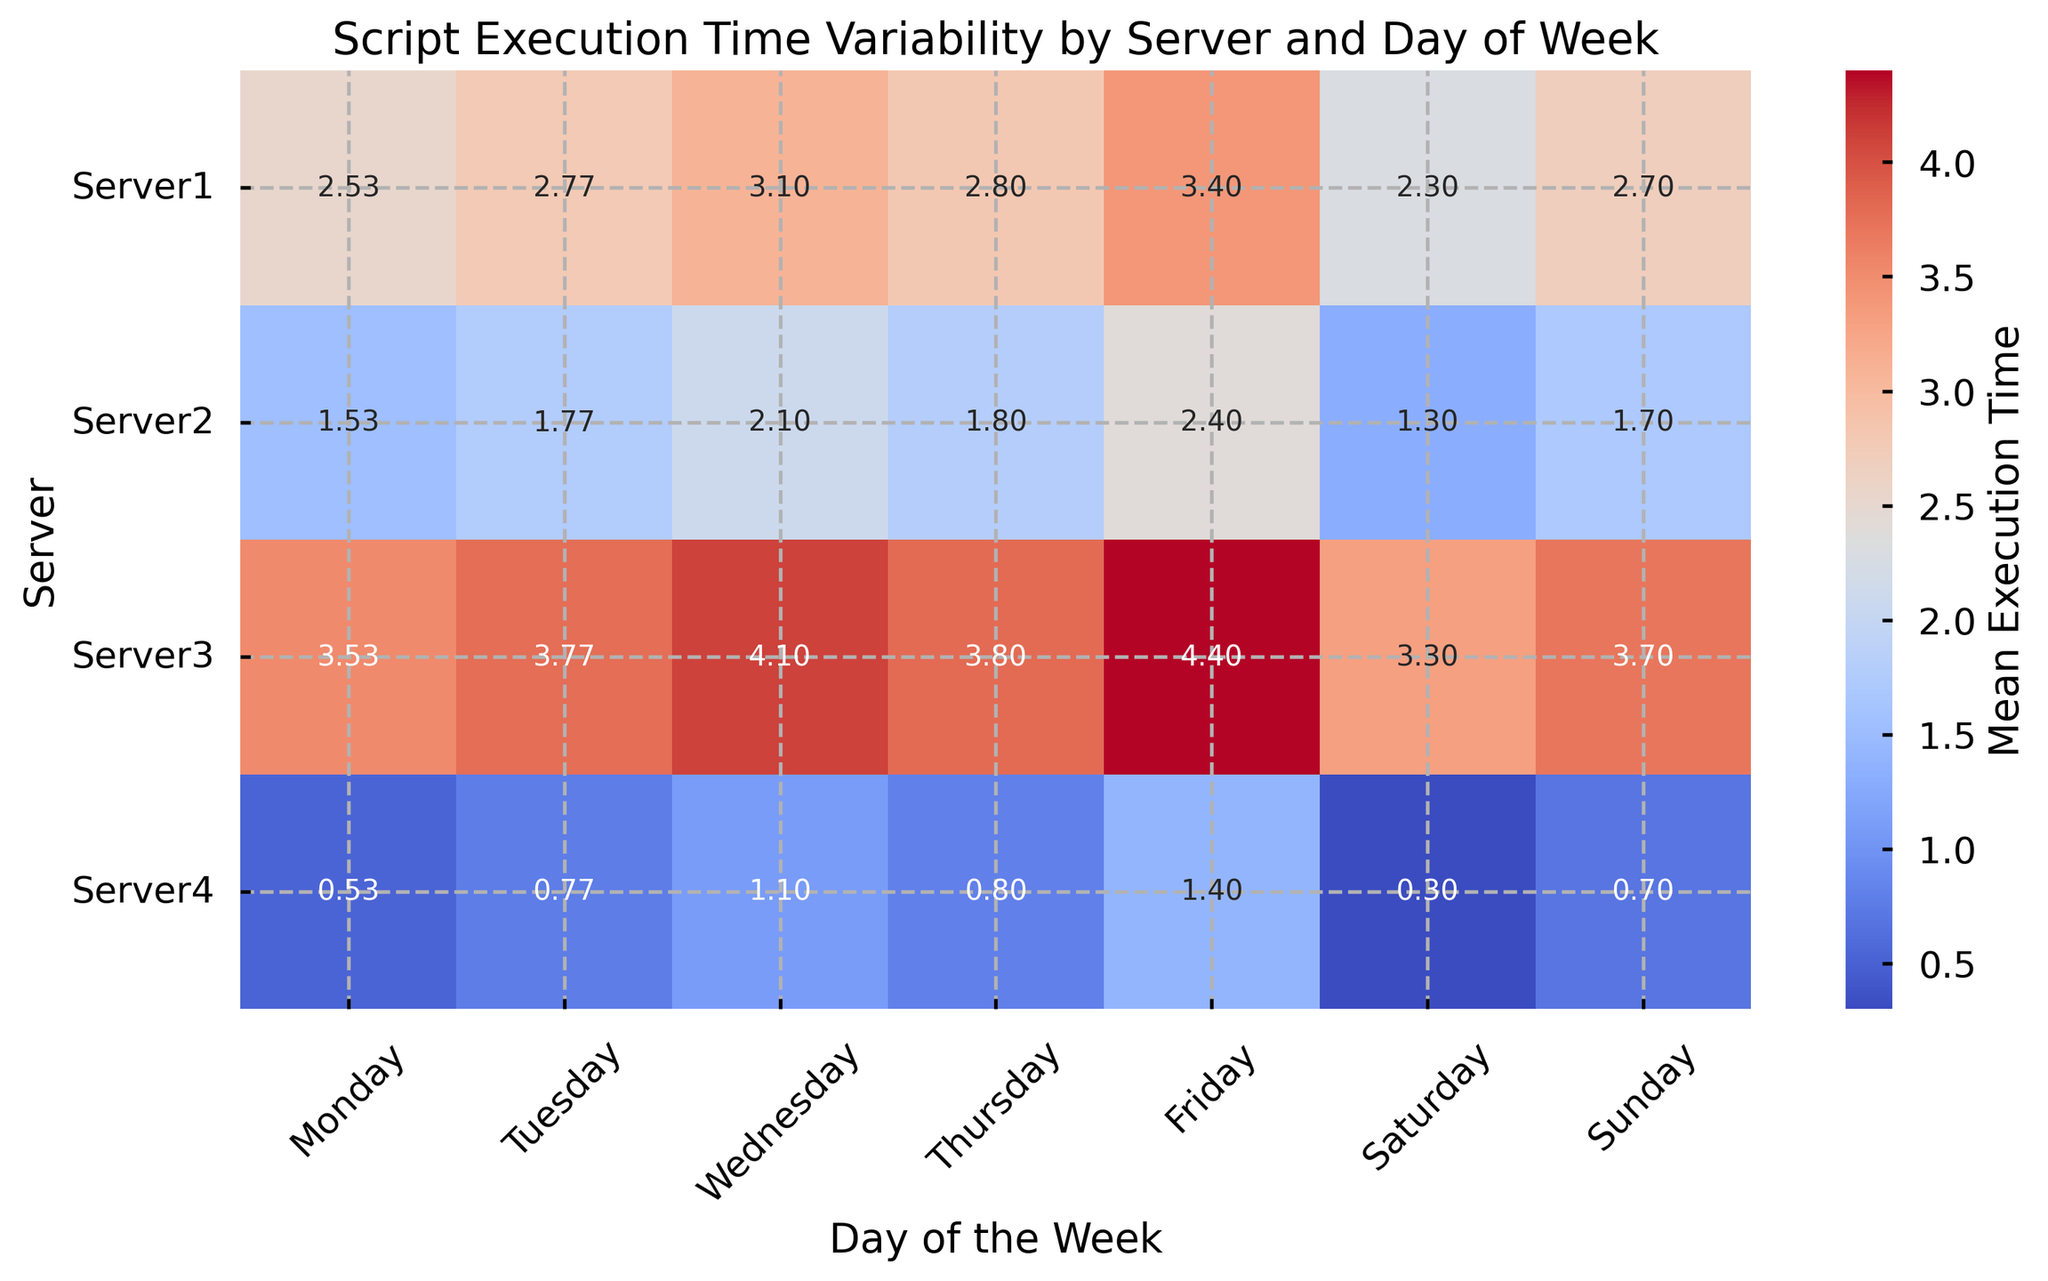Which server has the highest average execution time on Friday? To determine which server has the highest average on Friday, you look at the column labeled 'Friday' and identify the highest value. This value belongs to Server3 with an average execution time of 4.4.
Answer: Server3 Which day has the lowest average execution time for Server2? Look at the row labeled 'Server2' and identify the lowest value across all columns (days). The lowest average execution time for Server2 is 1.2 on Saturday.
Answer: Saturday Compare the execution times on Monday between Server1 and Server3. On Monday, Server1 has an average execution time of 2.53 and Server3 has an average execution time of 3.53. Comparing the two, Server3 has a higher execution time.
Answer: Server3 has the higher execution time What is the difference in the average execution time between Server4 and Server1 on Sunday? Look at the column labeled 'Sunday' for Server4 and Server1. For Server4, the average execution time is 0.7; for Server1, it is 2.7. The difference is 2.7 - 0.7 = 2.
Answer: 2 For Server3, which day has the second highest average execution time and what is it? For Server3, you identify the highest value first (Friday, 4.4), then the second highest value (Wednesday, 4.1).
Answer: Wednesday, 4.1 How does the average execution time on Tuesday for Server2 compare to that on Wednesday for the same server? For Server2, check the average execution times for Tuesday and Wednesday. Tuesday is 1.77 and Wednesday is 2.1. Since 1.77 < 2.1, Tuesday has a lower execution time.
Answer: Tuesday has a lower execution time What is the combined average execution time for Server1 on Monday and Tuesday? Look at Server1's averages for Monday (2.53) and Tuesday (2.77), then sum them up. The combined average is 2.53 + 2.77 = 5.3.
Answer: 5.3 Which server shows more variability in execution times throughout the week? To determine variability, observe the range of average execution times for each server across all days. Server3 ranges from 3.2 to 4.4, indicating higher variability than the other servers which have narrower ranges.
Answer: Server3 On Thursday, which server has the closest average execution time to 2.0? Examine the Thursday column and find the server with a value closest to 2.0. Server2 has an average execution time of 1.8, which is the closest to 2.0.
Answer: Server2 Which server has a consistently low execution time across all days of the week? Look across all rows to find a server with low and consistent execution times. Server4 consistently has low values ranging from 0.2 to 1.5, fitting this description.
Answer: Server4 